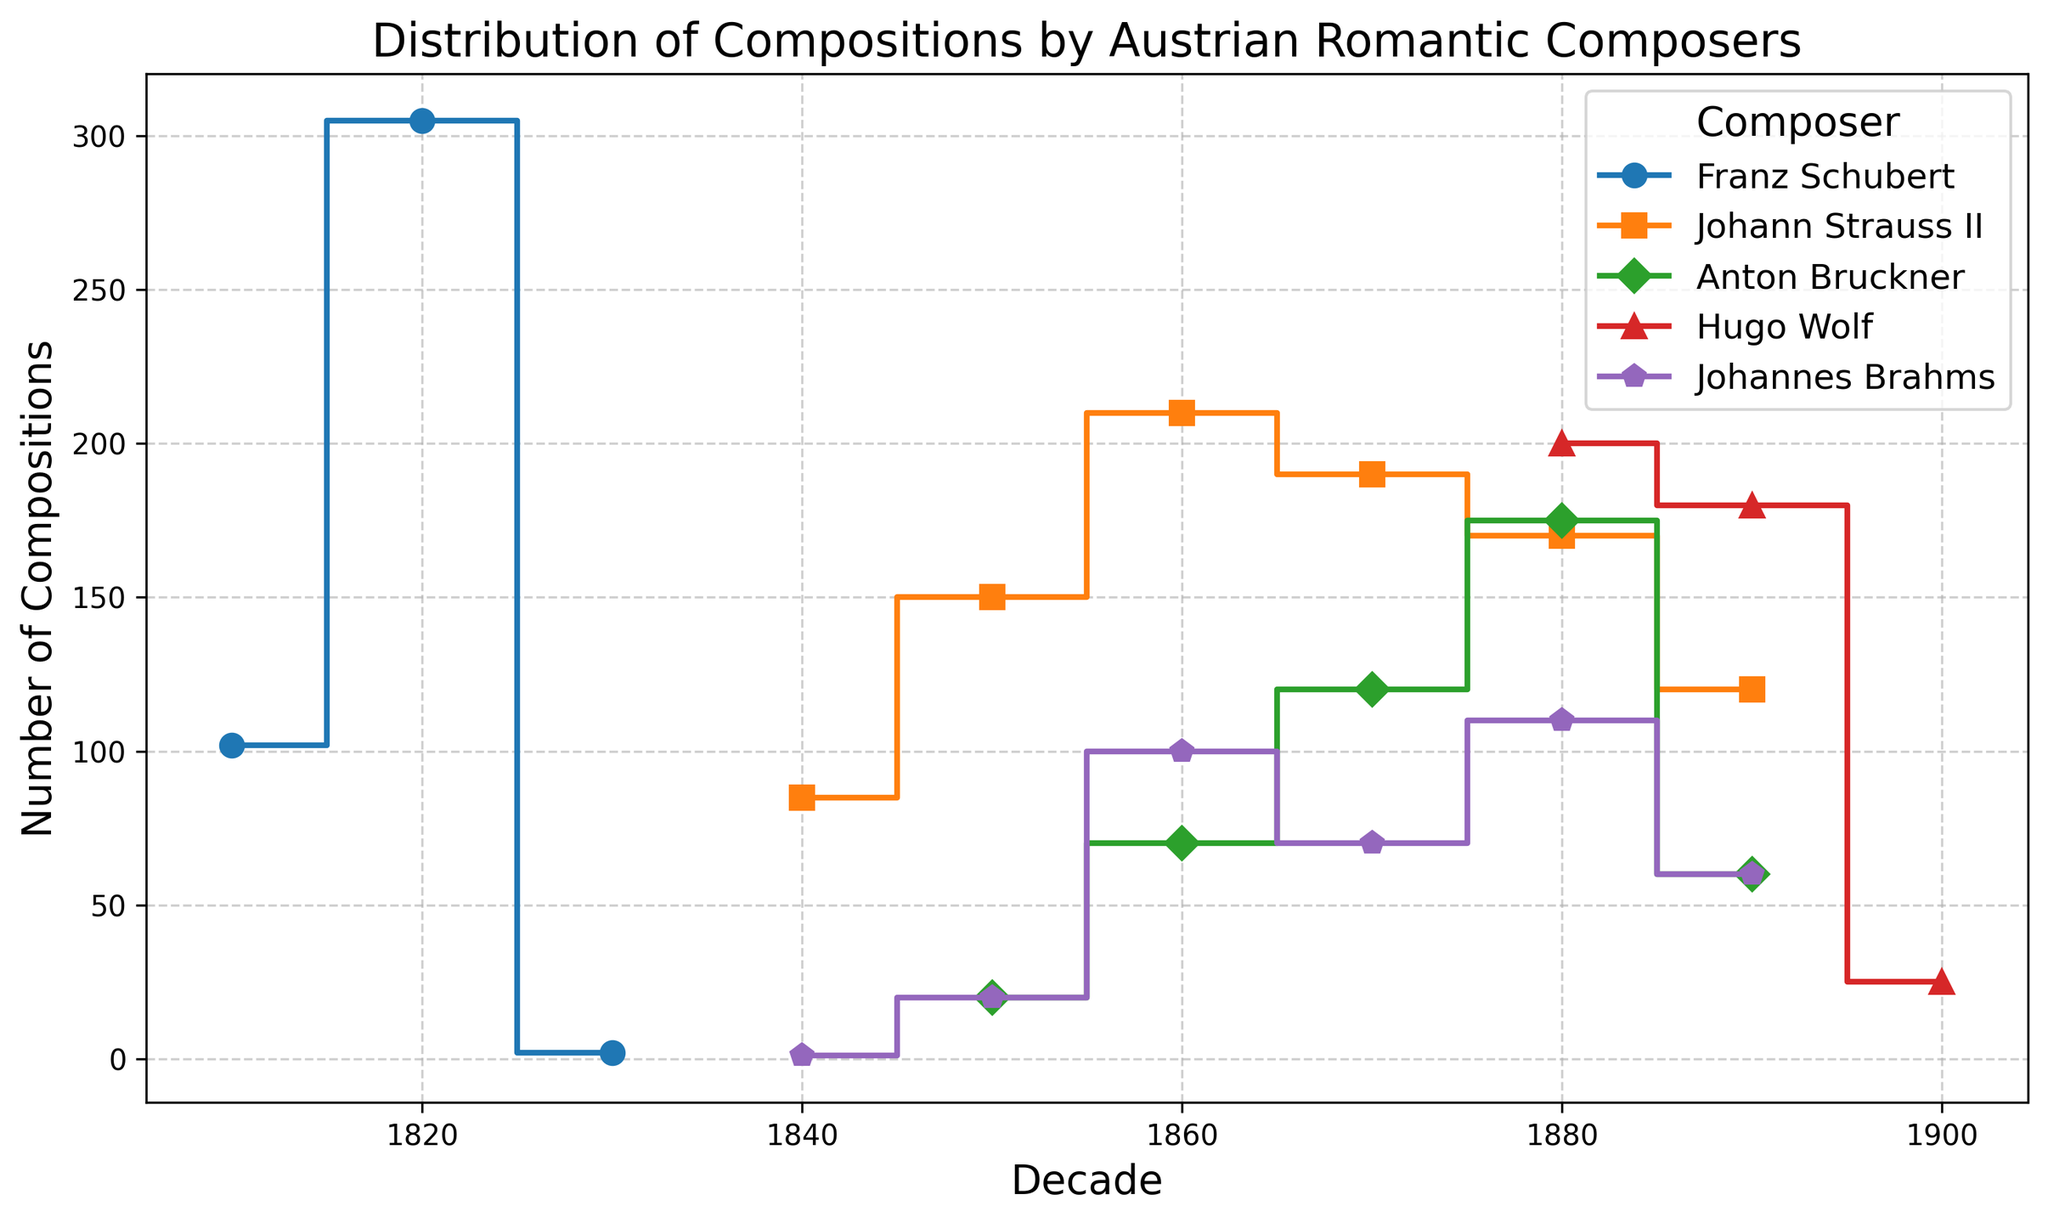What's the total number of compositions by Franz Schubert in the 1810s and 1820s? To find the total number of compositions by Franz Schubert in the 1810s and 1820s, add the counts for both decades: 102 (1810s) + 305 (1820s) = 407.
Answer: 407 Which composer has the highest peak in the number of compositions in any given decade? The highest peak can be found by identifying the tallest point on the plot. For Franz Schubert in the 1820s, the count is 305, which is the highest of all peaks on the plot.
Answer: Franz Schubert During which decade did Johann Strauss II compose the most pieces? Johann Strauss II's highest point can be determined by finding the tallest step in his plot line. His peak is in the 1860s with 210 compositions.
Answer: 1860s Compare the number of compositions between Anton Bruckner in the 1880s and Hugo Wolf in the same decade. To compare, look at the counts for each composer in the 1880s. Anton Bruckner has 175 compositions, while Hugo Wolf has 200 compositions.
Answer: Hugo Wolf What is the average number of compositions by Johannes Brahms across all decades? Calculate the average by adding the counts for each decade and then dividing by the number of decades: (1 + 20 + 100 + 70 + 110 + 60) / 6 = 361 / 6 ≈ 60.17.
Answer: 60.17 In which decades did Hugo Wolf have more compositions than Anton Bruckner? Compare the counts for Hugo Wolf and Anton Bruckner across each decade: 1880s (200 vs. 175) and 1890s (180 vs. 60). Hugo Wolf has more in both decades.
Answer: 1880s, 1890s Which composer shows a decreasing trend in compositions from the 1880s to 1900s? Observe the slopes of each composer's plot from the 1880s to 1900s. Hugo Wolf's line decreases from 200 in the 1880s to 180 in the 1890s, and further down to 25 in the 1900s.
Answer: Hugo Wolf Which decade shows the smallest number of compositions for Johannes Brahms? Locate the decade with the smallest count on Johannes Brahms's plot. The 1840s have only 1 composition, the smallest count.
Answer: 1840s 